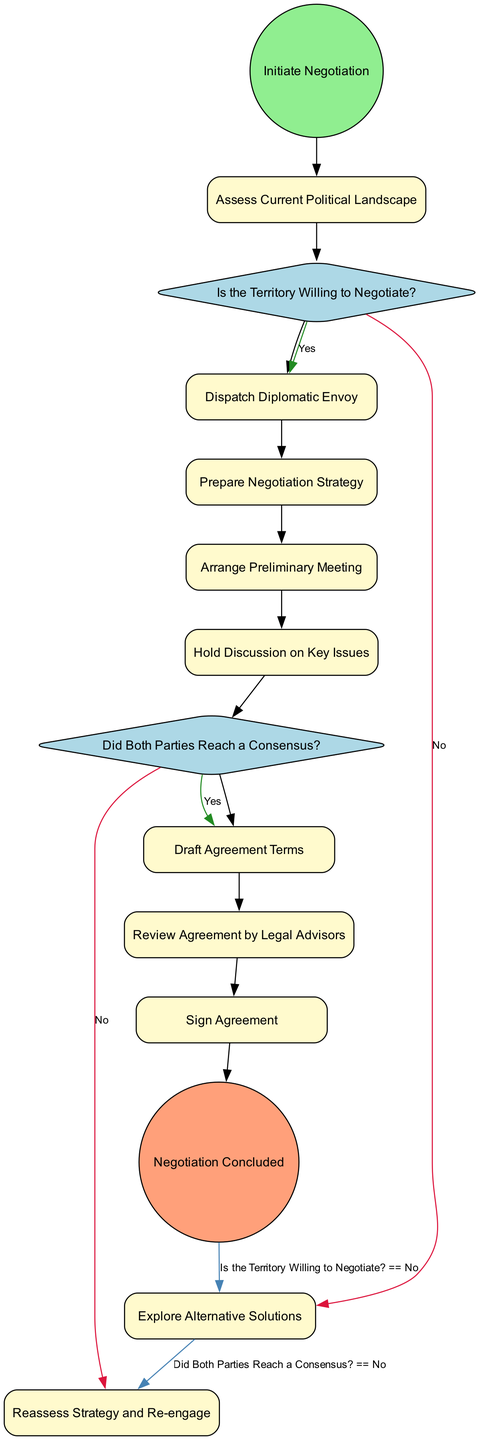What is the first activity in the diagram? The first activity represented in the diagram is "Assess Current Political Landscape" which directly follows the "Initiate Negotiation" start event.
Answer: Assess Current Political Landscape How many activities are there in total? There are six activities listed within the diagram, apart from start and end events. These activities are "Assess Current Political Landscape," "Dispatch Diplomatic Envoy," "Prepare Negotiation Strategy," "Arrange Preliminary Meeting," "Hold Discussion on Key Issues," and "Draft Agreement Terms."
Answer: Six What is the decision point following the "Dispatch Diplomatic Envoy"? The decision point that follows the "Dispatch Diplomatic Envoy" is labeled "Is the Territory Willing to Negotiate?" It is essential as it determines the next steps based on the willingness of the other territory.
Answer: Is the Territory Willing to Negotiate? What happens if the answer to the decision "Did Both Parties Reach a Consensus?" is No? If the answer is No to "Did Both Parties Reach a Consensus?", the next activity is "Reassess Strategy and Re-engage," indicating that further negotiations are needed before an agreement can be reached.
Answer: Reassess Strategy and Re-engage How many decision points are included in the diagram? There are two decision points in the diagram: "Is the Territory Willing to Negotiate?" and "Did Both Parties Reach a Consensus?" These points facilitate branching paths based on conditions that influence the negotiation process.
Answer: Two Which activity immediately leads to the "Sign Agreement"? The activity that directly precedes "Sign Agreement" is "Review Agreement by Legal Advisors." It is essential to ensure that all legal aspects of the agreement have been examined before signing.
Answer: Review Agreement by Legal Advisors What occurs at the end of the negotiation process? At the conclusion of the negotiation process, the final event is "Negotiation Concluded," indicating that all steps have been completed satisfactorily and the agreement is finalized.
Answer: Negotiation Concluded 